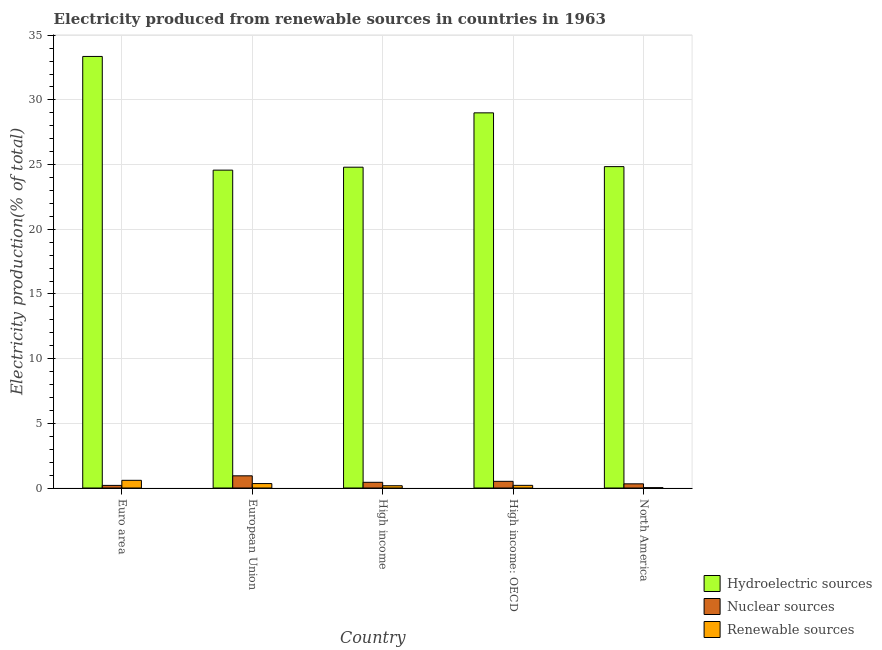How many groups of bars are there?
Your answer should be very brief. 5. What is the label of the 1st group of bars from the left?
Give a very brief answer. Euro area. In how many cases, is the number of bars for a given country not equal to the number of legend labels?
Make the answer very short. 0. What is the percentage of electricity produced by renewable sources in Euro area?
Give a very brief answer. 0.59. Across all countries, what is the maximum percentage of electricity produced by hydroelectric sources?
Offer a very short reply. 33.36. Across all countries, what is the minimum percentage of electricity produced by renewable sources?
Offer a terse response. 0.03. What is the total percentage of electricity produced by hydroelectric sources in the graph?
Keep it short and to the point. 136.58. What is the difference between the percentage of electricity produced by hydroelectric sources in European Union and that in North America?
Your response must be concise. -0.27. What is the difference between the percentage of electricity produced by hydroelectric sources in High income: OECD and the percentage of electricity produced by nuclear sources in High income?
Provide a succinct answer. 28.56. What is the average percentage of electricity produced by hydroelectric sources per country?
Your response must be concise. 27.32. What is the difference between the percentage of electricity produced by hydroelectric sources and percentage of electricity produced by renewable sources in European Union?
Offer a terse response. 24.23. In how many countries, is the percentage of electricity produced by hydroelectric sources greater than 26 %?
Offer a terse response. 2. What is the ratio of the percentage of electricity produced by hydroelectric sources in Euro area to that in North America?
Offer a very short reply. 1.34. What is the difference between the highest and the second highest percentage of electricity produced by nuclear sources?
Your answer should be very brief. 0.43. What is the difference between the highest and the lowest percentage of electricity produced by hydroelectric sources?
Your answer should be very brief. 8.79. In how many countries, is the percentage of electricity produced by nuclear sources greater than the average percentage of electricity produced by nuclear sources taken over all countries?
Keep it short and to the point. 2. What does the 2nd bar from the left in High income represents?
Offer a very short reply. Nuclear sources. What does the 2nd bar from the right in North America represents?
Offer a very short reply. Nuclear sources. Is it the case that in every country, the sum of the percentage of electricity produced by hydroelectric sources and percentage of electricity produced by nuclear sources is greater than the percentage of electricity produced by renewable sources?
Provide a short and direct response. Yes. Are all the bars in the graph horizontal?
Provide a short and direct response. No. How many countries are there in the graph?
Keep it short and to the point. 5. What is the difference between two consecutive major ticks on the Y-axis?
Provide a short and direct response. 5. Are the values on the major ticks of Y-axis written in scientific E-notation?
Your answer should be very brief. No. Does the graph contain any zero values?
Your answer should be very brief. No. How are the legend labels stacked?
Ensure brevity in your answer.  Vertical. What is the title of the graph?
Provide a succinct answer. Electricity produced from renewable sources in countries in 1963. What is the label or title of the X-axis?
Your answer should be compact. Country. What is the Electricity production(% of total) in Hydroelectric sources in Euro area?
Offer a very short reply. 33.36. What is the Electricity production(% of total) in Nuclear sources in Euro area?
Your answer should be very brief. 0.2. What is the Electricity production(% of total) of Renewable sources in Euro area?
Provide a succinct answer. 0.59. What is the Electricity production(% of total) of Hydroelectric sources in European Union?
Offer a terse response. 24.57. What is the Electricity production(% of total) of Nuclear sources in European Union?
Give a very brief answer. 0.94. What is the Electricity production(% of total) in Renewable sources in European Union?
Your response must be concise. 0.34. What is the Electricity production(% of total) of Hydroelectric sources in High income?
Give a very brief answer. 24.8. What is the Electricity production(% of total) in Nuclear sources in High income?
Ensure brevity in your answer.  0.44. What is the Electricity production(% of total) of Renewable sources in High income?
Keep it short and to the point. 0.18. What is the Electricity production(% of total) of Hydroelectric sources in High income: OECD?
Offer a terse response. 29. What is the Electricity production(% of total) of Nuclear sources in High income: OECD?
Offer a very short reply. 0.52. What is the Electricity production(% of total) in Renewable sources in High income: OECD?
Your answer should be compact. 0.21. What is the Electricity production(% of total) of Hydroelectric sources in North America?
Make the answer very short. 24.84. What is the Electricity production(% of total) of Nuclear sources in North America?
Your response must be concise. 0.32. What is the Electricity production(% of total) of Renewable sources in North America?
Your answer should be very brief. 0.03. Across all countries, what is the maximum Electricity production(% of total) of Hydroelectric sources?
Offer a very short reply. 33.36. Across all countries, what is the maximum Electricity production(% of total) in Nuclear sources?
Your answer should be very brief. 0.94. Across all countries, what is the maximum Electricity production(% of total) in Renewable sources?
Make the answer very short. 0.59. Across all countries, what is the minimum Electricity production(% of total) in Hydroelectric sources?
Provide a short and direct response. 24.57. Across all countries, what is the minimum Electricity production(% of total) of Nuclear sources?
Offer a very short reply. 0.2. Across all countries, what is the minimum Electricity production(% of total) of Renewable sources?
Make the answer very short. 0.03. What is the total Electricity production(% of total) of Hydroelectric sources in the graph?
Your answer should be compact. 136.58. What is the total Electricity production(% of total) of Nuclear sources in the graph?
Offer a terse response. 2.42. What is the total Electricity production(% of total) of Renewable sources in the graph?
Ensure brevity in your answer.  1.34. What is the difference between the Electricity production(% of total) in Hydroelectric sources in Euro area and that in European Union?
Make the answer very short. 8.79. What is the difference between the Electricity production(% of total) in Nuclear sources in Euro area and that in European Union?
Keep it short and to the point. -0.74. What is the difference between the Electricity production(% of total) in Renewable sources in Euro area and that in European Union?
Your answer should be very brief. 0.25. What is the difference between the Electricity production(% of total) of Hydroelectric sources in Euro area and that in High income?
Provide a succinct answer. 8.56. What is the difference between the Electricity production(% of total) of Nuclear sources in Euro area and that in High income?
Your response must be concise. -0.24. What is the difference between the Electricity production(% of total) of Renewable sources in Euro area and that in High income?
Make the answer very short. 0.42. What is the difference between the Electricity production(% of total) in Hydroelectric sources in Euro area and that in High income: OECD?
Keep it short and to the point. 4.36. What is the difference between the Electricity production(% of total) of Nuclear sources in Euro area and that in High income: OECD?
Your answer should be compact. -0.31. What is the difference between the Electricity production(% of total) in Renewable sources in Euro area and that in High income: OECD?
Your answer should be compact. 0.39. What is the difference between the Electricity production(% of total) in Hydroelectric sources in Euro area and that in North America?
Provide a succinct answer. 8.52. What is the difference between the Electricity production(% of total) of Nuclear sources in Euro area and that in North America?
Give a very brief answer. -0.12. What is the difference between the Electricity production(% of total) in Renewable sources in Euro area and that in North America?
Make the answer very short. 0.57. What is the difference between the Electricity production(% of total) in Hydroelectric sources in European Union and that in High income?
Offer a very short reply. -0.23. What is the difference between the Electricity production(% of total) in Nuclear sources in European Union and that in High income?
Offer a terse response. 0.5. What is the difference between the Electricity production(% of total) of Renewable sources in European Union and that in High income?
Provide a short and direct response. 0.17. What is the difference between the Electricity production(% of total) in Hydroelectric sources in European Union and that in High income: OECD?
Your answer should be compact. -4.43. What is the difference between the Electricity production(% of total) in Nuclear sources in European Union and that in High income: OECD?
Make the answer very short. 0.43. What is the difference between the Electricity production(% of total) of Renewable sources in European Union and that in High income: OECD?
Your answer should be compact. 0.14. What is the difference between the Electricity production(% of total) in Hydroelectric sources in European Union and that in North America?
Your response must be concise. -0.27. What is the difference between the Electricity production(% of total) of Nuclear sources in European Union and that in North America?
Ensure brevity in your answer.  0.62. What is the difference between the Electricity production(% of total) in Renewable sources in European Union and that in North America?
Provide a short and direct response. 0.32. What is the difference between the Electricity production(% of total) of Hydroelectric sources in High income and that in High income: OECD?
Give a very brief answer. -4.2. What is the difference between the Electricity production(% of total) in Nuclear sources in High income and that in High income: OECD?
Your answer should be compact. -0.07. What is the difference between the Electricity production(% of total) of Renewable sources in High income and that in High income: OECD?
Provide a succinct answer. -0.03. What is the difference between the Electricity production(% of total) in Hydroelectric sources in High income and that in North America?
Your answer should be very brief. -0.04. What is the difference between the Electricity production(% of total) of Nuclear sources in High income and that in North America?
Your response must be concise. 0.12. What is the difference between the Electricity production(% of total) in Renewable sources in High income and that in North America?
Provide a short and direct response. 0.15. What is the difference between the Electricity production(% of total) of Hydroelectric sources in High income: OECD and that in North America?
Give a very brief answer. 4.16. What is the difference between the Electricity production(% of total) of Nuclear sources in High income: OECD and that in North America?
Your answer should be very brief. 0.19. What is the difference between the Electricity production(% of total) of Renewable sources in High income: OECD and that in North America?
Give a very brief answer. 0.18. What is the difference between the Electricity production(% of total) of Hydroelectric sources in Euro area and the Electricity production(% of total) of Nuclear sources in European Union?
Offer a terse response. 32.42. What is the difference between the Electricity production(% of total) in Hydroelectric sources in Euro area and the Electricity production(% of total) in Renewable sources in European Union?
Provide a short and direct response. 33.02. What is the difference between the Electricity production(% of total) in Nuclear sources in Euro area and the Electricity production(% of total) in Renewable sources in European Union?
Your answer should be very brief. -0.14. What is the difference between the Electricity production(% of total) in Hydroelectric sources in Euro area and the Electricity production(% of total) in Nuclear sources in High income?
Provide a short and direct response. 32.92. What is the difference between the Electricity production(% of total) of Hydroelectric sources in Euro area and the Electricity production(% of total) of Renewable sources in High income?
Provide a succinct answer. 33.19. What is the difference between the Electricity production(% of total) in Nuclear sources in Euro area and the Electricity production(% of total) in Renewable sources in High income?
Keep it short and to the point. 0.03. What is the difference between the Electricity production(% of total) in Hydroelectric sources in Euro area and the Electricity production(% of total) in Nuclear sources in High income: OECD?
Offer a very short reply. 32.85. What is the difference between the Electricity production(% of total) in Hydroelectric sources in Euro area and the Electricity production(% of total) in Renewable sources in High income: OECD?
Make the answer very short. 33.16. What is the difference between the Electricity production(% of total) in Nuclear sources in Euro area and the Electricity production(% of total) in Renewable sources in High income: OECD?
Keep it short and to the point. -0. What is the difference between the Electricity production(% of total) in Hydroelectric sources in Euro area and the Electricity production(% of total) in Nuclear sources in North America?
Offer a terse response. 33.04. What is the difference between the Electricity production(% of total) of Hydroelectric sources in Euro area and the Electricity production(% of total) of Renewable sources in North America?
Keep it short and to the point. 33.34. What is the difference between the Electricity production(% of total) in Nuclear sources in Euro area and the Electricity production(% of total) in Renewable sources in North America?
Your answer should be compact. 0.18. What is the difference between the Electricity production(% of total) of Hydroelectric sources in European Union and the Electricity production(% of total) of Nuclear sources in High income?
Provide a short and direct response. 24.13. What is the difference between the Electricity production(% of total) in Hydroelectric sources in European Union and the Electricity production(% of total) in Renewable sources in High income?
Make the answer very short. 24.4. What is the difference between the Electricity production(% of total) of Nuclear sources in European Union and the Electricity production(% of total) of Renewable sources in High income?
Keep it short and to the point. 0.77. What is the difference between the Electricity production(% of total) in Hydroelectric sources in European Union and the Electricity production(% of total) in Nuclear sources in High income: OECD?
Keep it short and to the point. 24.06. What is the difference between the Electricity production(% of total) of Hydroelectric sources in European Union and the Electricity production(% of total) of Renewable sources in High income: OECD?
Keep it short and to the point. 24.37. What is the difference between the Electricity production(% of total) in Nuclear sources in European Union and the Electricity production(% of total) in Renewable sources in High income: OECD?
Provide a short and direct response. 0.74. What is the difference between the Electricity production(% of total) in Hydroelectric sources in European Union and the Electricity production(% of total) in Nuclear sources in North America?
Ensure brevity in your answer.  24.25. What is the difference between the Electricity production(% of total) of Hydroelectric sources in European Union and the Electricity production(% of total) of Renewable sources in North America?
Give a very brief answer. 24.55. What is the difference between the Electricity production(% of total) in Nuclear sources in European Union and the Electricity production(% of total) in Renewable sources in North America?
Offer a very short reply. 0.92. What is the difference between the Electricity production(% of total) of Hydroelectric sources in High income and the Electricity production(% of total) of Nuclear sources in High income: OECD?
Your answer should be compact. 24.29. What is the difference between the Electricity production(% of total) of Hydroelectric sources in High income and the Electricity production(% of total) of Renewable sources in High income: OECD?
Offer a very short reply. 24.6. What is the difference between the Electricity production(% of total) of Nuclear sources in High income and the Electricity production(% of total) of Renewable sources in High income: OECD?
Your answer should be very brief. 0.24. What is the difference between the Electricity production(% of total) in Hydroelectric sources in High income and the Electricity production(% of total) in Nuclear sources in North America?
Give a very brief answer. 24.48. What is the difference between the Electricity production(% of total) in Hydroelectric sources in High income and the Electricity production(% of total) in Renewable sources in North America?
Provide a short and direct response. 24.77. What is the difference between the Electricity production(% of total) in Nuclear sources in High income and the Electricity production(% of total) in Renewable sources in North America?
Give a very brief answer. 0.41. What is the difference between the Electricity production(% of total) of Hydroelectric sources in High income: OECD and the Electricity production(% of total) of Nuclear sources in North America?
Offer a terse response. 28.68. What is the difference between the Electricity production(% of total) of Hydroelectric sources in High income: OECD and the Electricity production(% of total) of Renewable sources in North America?
Your response must be concise. 28.98. What is the difference between the Electricity production(% of total) of Nuclear sources in High income: OECD and the Electricity production(% of total) of Renewable sources in North America?
Your answer should be compact. 0.49. What is the average Electricity production(% of total) in Hydroelectric sources per country?
Give a very brief answer. 27.32. What is the average Electricity production(% of total) of Nuclear sources per country?
Offer a terse response. 0.48. What is the average Electricity production(% of total) of Renewable sources per country?
Your response must be concise. 0.27. What is the difference between the Electricity production(% of total) in Hydroelectric sources and Electricity production(% of total) in Nuclear sources in Euro area?
Offer a terse response. 33.16. What is the difference between the Electricity production(% of total) in Hydroelectric sources and Electricity production(% of total) in Renewable sources in Euro area?
Offer a very short reply. 32.77. What is the difference between the Electricity production(% of total) of Nuclear sources and Electricity production(% of total) of Renewable sources in Euro area?
Your answer should be very brief. -0.39. What is the difference between the Electricity production(% of total) in Hydroelectric sources and Electricity production(% of total) in Nuclear sources in European Union?
Give a very brief answer. 23.63. What is the difference between the Electricity production(% of total) in Hydroelectric sources and Electricity production(% of total) in Renewable sources in European Union?
Keep it short and to the point. 24.23. What is the difference between the Electricity production(% of total) in Nuclear sources and Electricity production(% of total) in Renewable sources in European Union?
Your answer should be very brief. 0.6. What is the difference between the Electricity production(% of total) of Hydroelectric sources and Electricity production(% of total) of Nuclear sources in High income?
Ensure brevity in your answer.  24.36. What is the difference between the Electricity production(% of total) in Hydroelectric sources and Electricity production(% of total) in Renewable sources in High income?
Provide a succinct answer. 24.63. What is the difference between the Electricity production(% of total) of Nuclear sources and Electricity production(% of total) of Renewable sources in High income?
Give a very brief answer. 0.27. What is the difference between the Electricity production(% of total) of Hydroelectric sources and Electricity production(% of total) of Nuclear sources in High income: OECD?
Give a very brief answer. 28.49. What is the difference between the Electricity production(% of total) in Hydroelectric sources and Electricity production(% of total) in Renewable sources in High income: OECD?
Your answer should be compact. 28.8. What is the difference between the Electricity production(% of total) in Nuclear sources and Electricity production(% of total) in Renewable sources in High income: OECD?
Give a very brief answer. 0.31. What is the difference between the Electricity production(% of total) of Hydroelectric sources and Electricity production(% of total) of Nuclear sources in North America?
Your response must be concise. 24.52. What is the difference between the Electricity production(% of total) of Hydroelectric sources and Electricity production(% of total) of Renewable sources in North America?
Your response must be concise. 24.82. What is the difference between the Electricity production(% of total) of Nuclear sources and Electricity production(% of total) of Renewable sources in North America?
Offer a very short reply. 0.3. What is the ratio of the Electricity production(% of total) in Hydroelectric sources in Euro area to that in European Union?
Provide a succinct answer. 1.36. What is the ratio of the Electricity production(% of total) in Nuclear sources in Euro area to that in European Union?
Keep it short and to the point. 0.21. What is the ratio of the Electricity production(% of total) in Renewable sources in Euro area to that in European Union?
Your response must be concise. 1.73. What is the ratio of the Electricity production(% of total) of Hydroelectric sources in Euro area to that in High income?
Provide a short and direct response. 1.35. What is the ratio of the Electricity production(% of total) in Nuclear sources in Euro area to that in High income?
Provide a short and direct response. 0.46. What is the ratio of the Electricity production(% of total) of Renewable sources in Euro area to that in High income?
Ensure brevity in your answer.  3.38. What is the ratio of the Electricity production(% of total) of Hydroelectric sources in Euro area to that in High income: OECD?
Give a very brief answer. 1.15. What is the ratio of the Electricity production(% of total) in Nuclear sources in Euro area to that in High income: OECD?
Your response must be concise. 0.39. What is the ratio of the Electricity production(% of total) in Renewable sources in Euro area to that in High income: OECD?
Offer a terse response. 2.89. What is the ratio of the Electricity production(% of total) in Hydroelectric sources in Euro area to that in North America?
Ensure brevity in your answer.  1.34. What is the ratio of the Electricity production(% of total) in Nuclear sources in Euro area to that in North America?
Your response must be concise. 0.63. What is the ratio of the Electricity production(% of total) in Renewable sources in Euro area to that in North America?
Offer a very short reply. 22.78. What is the ratio of the Electricity production(% of total) in Hydroelectric sources in European Union to that in High income?
Ensure brevity in your answer.  0.99. What is the ratio of the Electricity production(% of total) in Nuclear sources in European Union to that in High income?
Keep it short and to the point. 2.14. What is the ratio of the Electricity production(% of total) of Renewable sources in European Union to that in High income?
Your response must be concise. 1.95. What is the ratio of the Electricity production(% of total) in Hydroelectric sources in European Union to that in High income: OECD?
Provide a succinct answer. 0.85. What is the ratio of the Electricity production(% of total) in Nuclear sources in European Union to that in High income: OECD?
Your answer should be very brief. 1.83. What is the ratio of the Electricity production(% of total) of Renewable sources in European Union to that in High income: OECD?
Keep it short and to the point. 1.67. What is the ratio of the Electricity production(% of total) of Nuclear sources in European Union to that in North America?
Your answer should be compact. 2.92. What is the ratio of the Electricity production(% of total) of Renewable sources in European Union to that in North America?
Offer a very short reply. 13.14. What is the ratio of the Electricity production(% of total) in Hydroelectric sources in High income to that in High income: OECD?
Your response must be concise. 0.86. What is the ratio of the Electricity production(% of total) in Nuclear sources in High income to that in High income: OECD?
Keep it short and to the point. 0.86. What is the ratio of the Electricity production(% of total) in Renewable sources in High income to that in High income: OECD?
Your answer should be very brief. 0.86. What is the ratio of the Electricity production(% of total) of Hydroelectric sources in High income to that in North America?
Offer a very short reply. 1. What is the ratio of the Electricity production(% of total) in Nuclear sources in High income to that in North America?
Give a very brief answer. 1.37. What is the ratio of the Electricity production(% of total) in Renewable sources in High income to that in North America?
Make the answer very short. 6.73. What is the ratio of the Electricity production(% of total) of Hydroelectric sources in High income: OECD to that in North America?
Provide a short and direct response. 1.17. What is the ratio of the Electricity production(% of total) of Nuclear sources in High income: OECD to that in North America?
Give a very brief answer. 1.6. What is the ratio of the Electricity production(% of total) of Renewable sources in High income: OECD to that in North America?
Your response must be concise. 7.87. What is the difference between the highest and the second highest Electricity production(% of total) in Hydroelectric sources?
Your response must be concise. 4.36. What is the difference between the highest and the second highest Electricity production(% of total) in Nuclear sources?
Your answer should be compact. 0.43. What is the difference between the highest and the second highest Electricity production(% of total) in Renewable sources?
Provide a succinct answer. 0.25. What is the difference between the highest and the lowest Electricity production(% of total) of Hydroelectric sources?
Your answer should be very brief. 8.79. What is the difference between the highest and the lowest Electricity production(% of total) of Nuclear sources?
Offer a terse response. 0.74. What is the difference between the highest and the lowest Electricity production(% of total) in Renewable sources?
Ensure brevity in your answer.  0.57. 